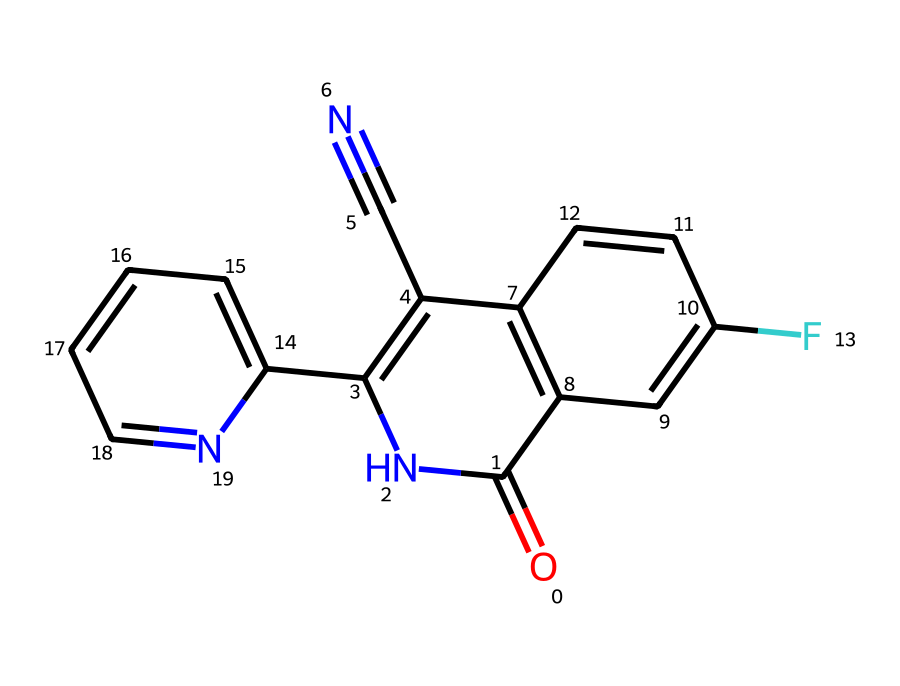how many rings are present in the molecular structure of fludioxonil? The molecular structure includes two distinct rings: one is a five-membered ring with nitrogen and the other is a six-membered ring. Counting these, we find a total of two rings present in the structure.
Answer: two what is the primary functional group in fludioxonil? In the given structure, the presence of the carbonyl group (C=O) indicates that fludioxonil contains amide functional characteristics, as the structure contains a nitrogen adjacent to the carbonyl.
Answer: amide how many nitrogen atoms are in the structure of fludioxonil? By examining the structural representation, we can identify three nitrogen atoms based on the presence of N within the structure, including those in the rings and side chains.
Answer: three what type of bonding is inferred between the carbon atoms in fludioxonil? The chemical structure indicates a combination of single and double bonds between carbon atoms, particularly showing the presence of double bonds in the aromatic rings and the carbonyl functional group.
Answer: both single and double bonds which part of fludioxonil contributes to its efficacy as a fungicide? The presence of the aromatic rings and the electronegative functional groups (like the fluorine) in the structure is critical, as these features enhance the compound's interaction with fungal enzymes, contributing to its efficacy as a fungicide.
Answer: aromatic rings and electronegative groups how does fludioxonil's molecular structure influence its stability? The presence of multiple aromatic rings in the structure adds resonance stability, while the functional groups may provide additional stabilization. Changes in bonding and the overall ring structure contribute positively to its chemical stability.
Answer: resonance stability what role does the cyano group play in the properties of fludioxonil? The cyano group (–C≡N) confers unique electronic properties, enhancing the compound’s ability to interact with biological targets and affecting its fungicidal activity. This group stabilizes the overall structure and may influence solubility.
Answer: interacts with biological targets 